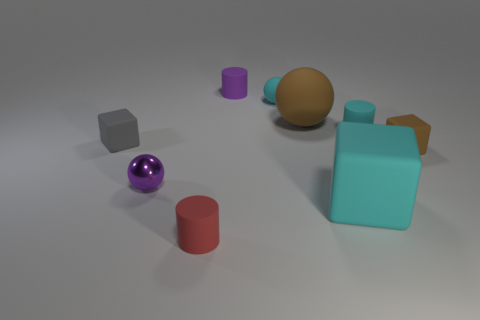Is there any other thing that is the same material as the purple ball?
Your answer should be very brief. No. What is the color of the sphere that is both left of the large brown matte sphere and behind the small cyan matte cylinder?
Provide a short and direct response. Cyan. There is a brown object that is in front of the matte cube on the left side of the shiny ball; is there a purple cylinder that is behind it?
Provide a succinct answer. Yes. What number of objects are tiny red metallic blocks or purple shiny spheres?
Offer a terse response. 1. Are the tiny gray object and the cyan object in front of the gray rubber thing made of the same material?
Offer a terse response. Yes. Is there any other thing that has the same color as the tiny shiny object?
Your answer should be compact. Yes. What number of objects are either blocks that are left of the small matte ball or small matte things in front of the tiny purple cylinder?
Provide a succinct answer. 5. What is the shape of the rubber thing that is in front of the tiny purple metal ball and on the left side of the tiny cyan matte sphere?
Your response must be concise. Cylinder. There is a cyan rubber thing to the right of the big cyan thing; how many small cyan matte cylinders are behind it?
Provide a succinct answer. 0. What number of objects are either small rubber objects behind the big brown ball or big red cylinders?
Provide a short and direct response. 2. 